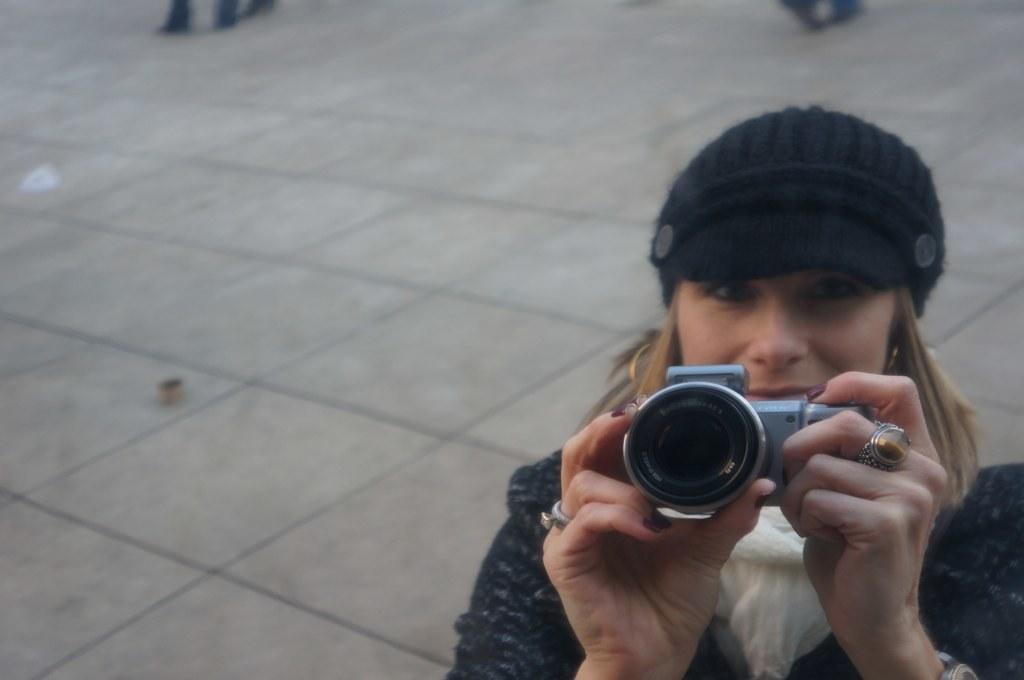Could you give a brief overview of what you see in this image? This woman wore black jacket, cap and holding a camera. 